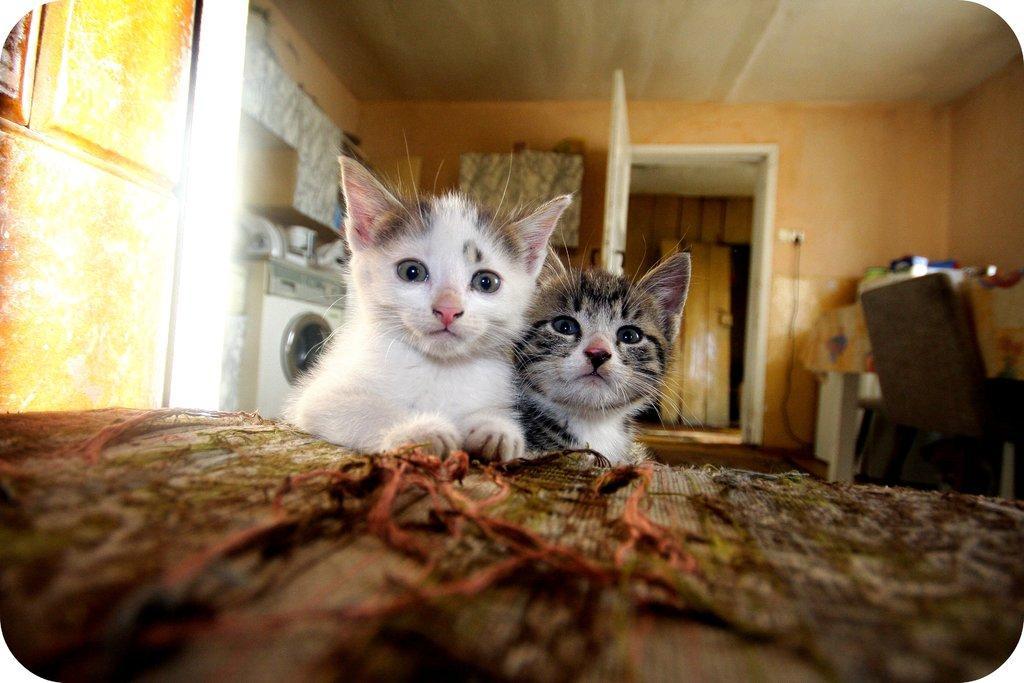Describe this image in one or two sentences. Here there are 2 cats behind them there is a washing machine,door,wall,chair. 